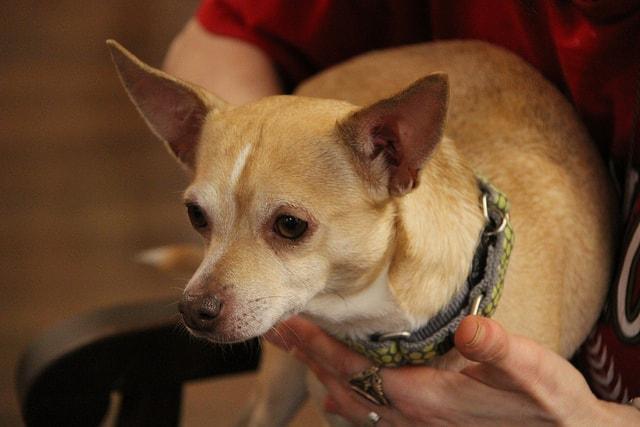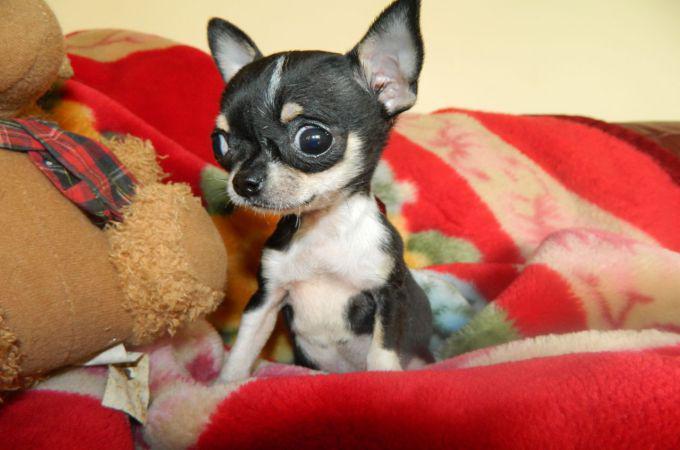The first image is the image on the left, the second image is the image on the right. For the images shown, is this caption "The dog in the image on the right is being held by a human." true? Answer yes or no. No. The first image is the image on the left, the second image is the image on the right. Considering the images on both sides, is "A person is holding the dog in the image on the right." valid? Answer yes or no. No. 